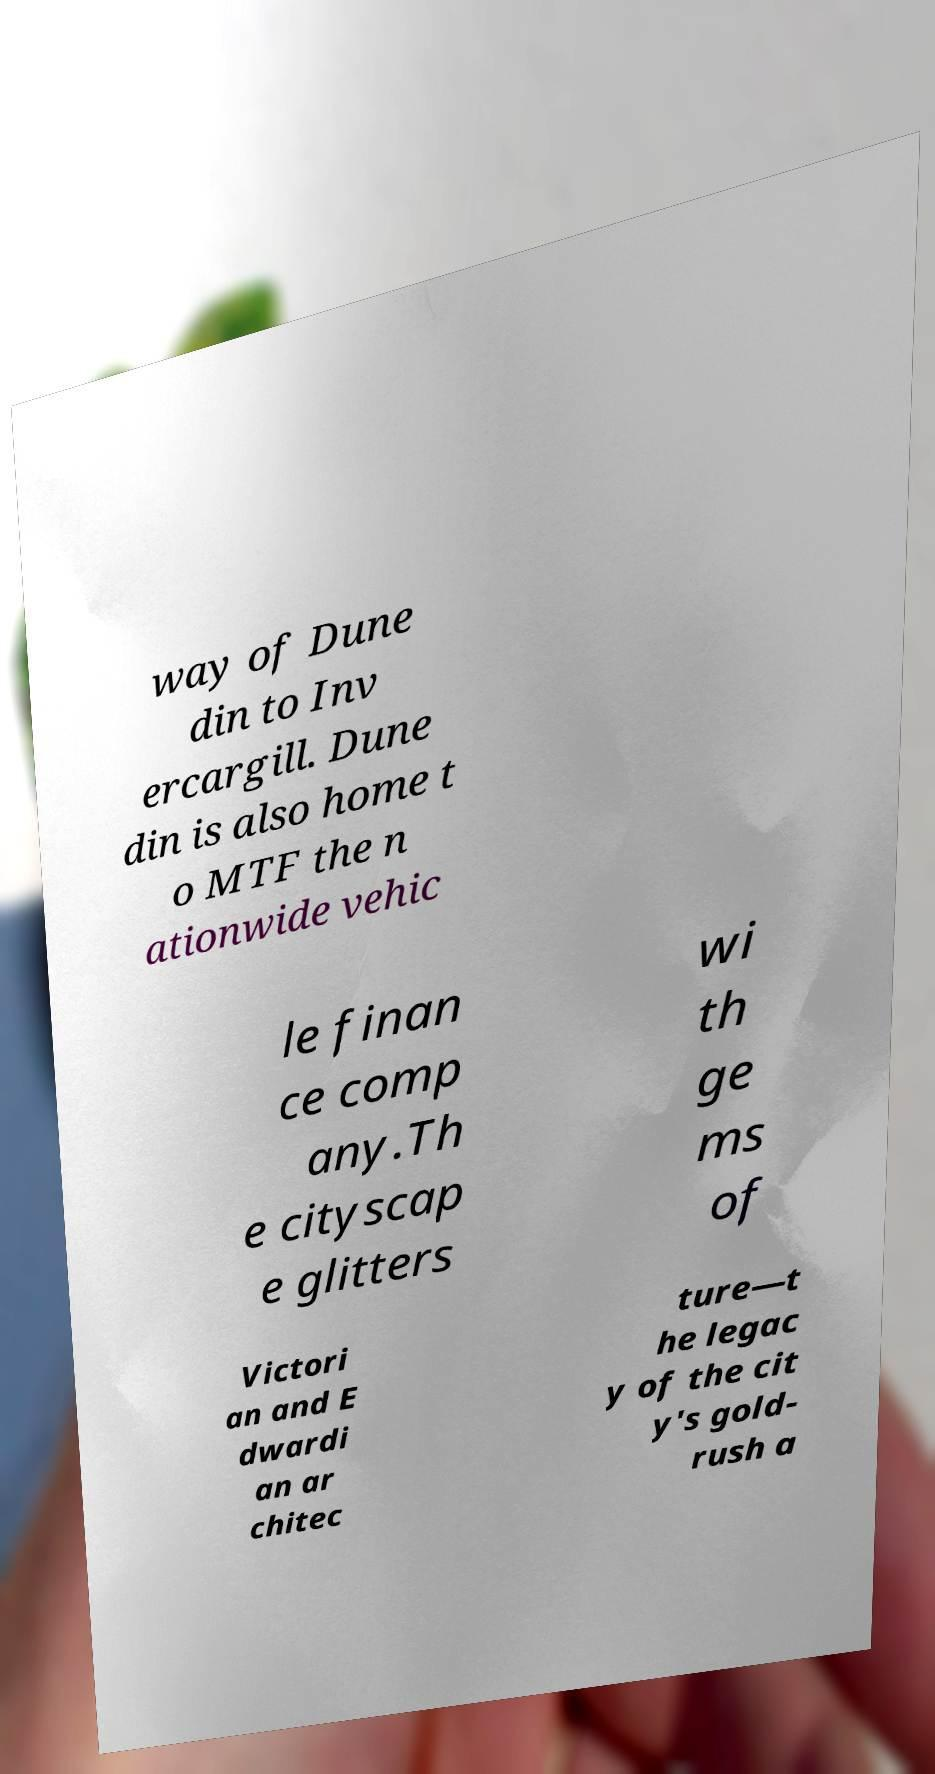For documentation purposes, I need the text within this image transcribed. Could you provide that? way of Dune din to Inv ercargill. Dune din is also home t o MTF the n ationwide vehic le finan ce comp any.Th e cityscap e glitters wi th ge ms of Victori an and E dwardi an ar chitec ture—t he legac y of the cit y's gold- rush a 